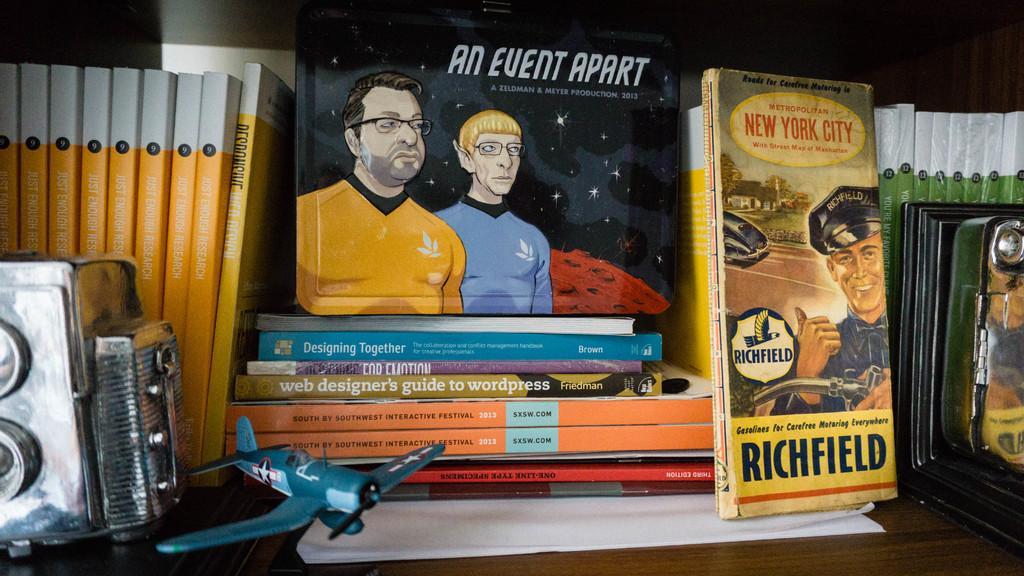In one or two sentences, can you explain what this image depicts? In this image I can see the brown colored wooden surface and on it I can see a toy aircraft, a camera and number of books. I can see the white and black colored background. 